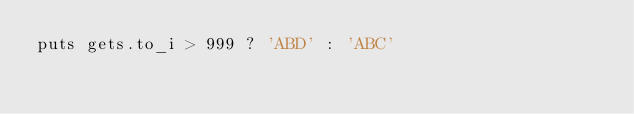<code> <loc_0><loc_0><loc_500><loc_500><_Ruby_>puts gets.to_i > 999 ? 'ABD' : 'ABC'
</code> 